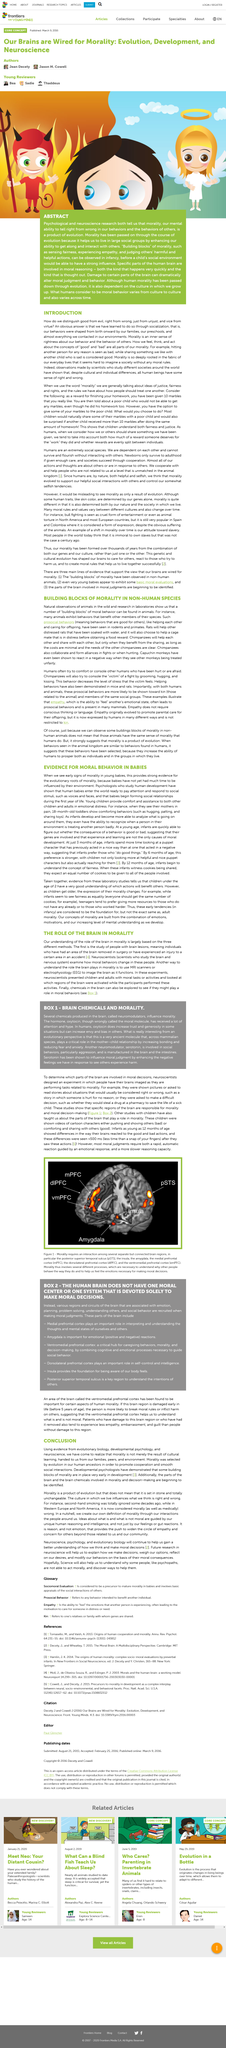Identify some key points in this picture. The realization that morality is not merely the result of cultural learning has been informed by evidence from various fields of study, including evolutionary biology, developmental psychology, and neuroscience, which have provided compelling insights into the innate nature of moral principles. Developmental psychologists have proven that the building blocks of morality are developed early in human development. Yes, parts of the brain and its chemicals are being identified as being involved in morality and decision-making. 